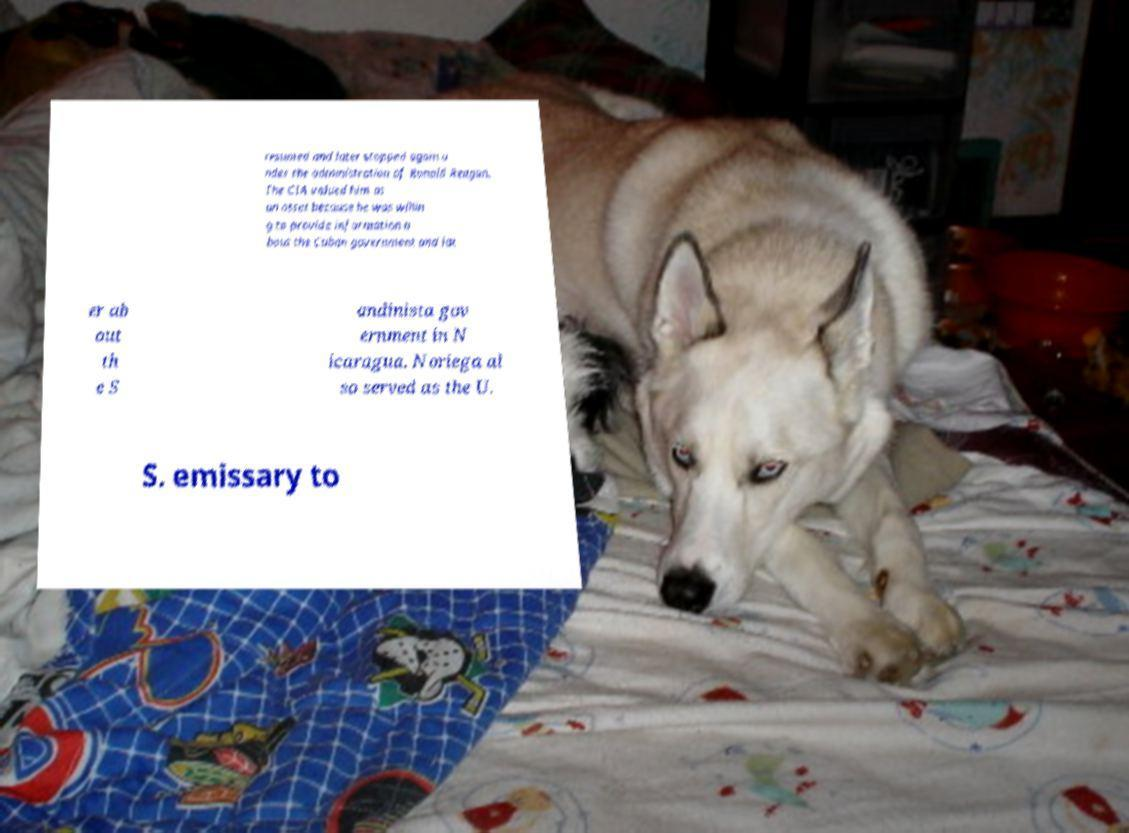What messages or text are displayed in this image? I need them in a readable, typed format. resumed and later stopped again u nder the administration of Ronald Reagan. The CIA valued him as an asset because he was willin g to provide information a bout the Cuban government and lat er ab out th e S andinista gov ernment in N icaragua. Noriega al so served as the U. S. emissary to 